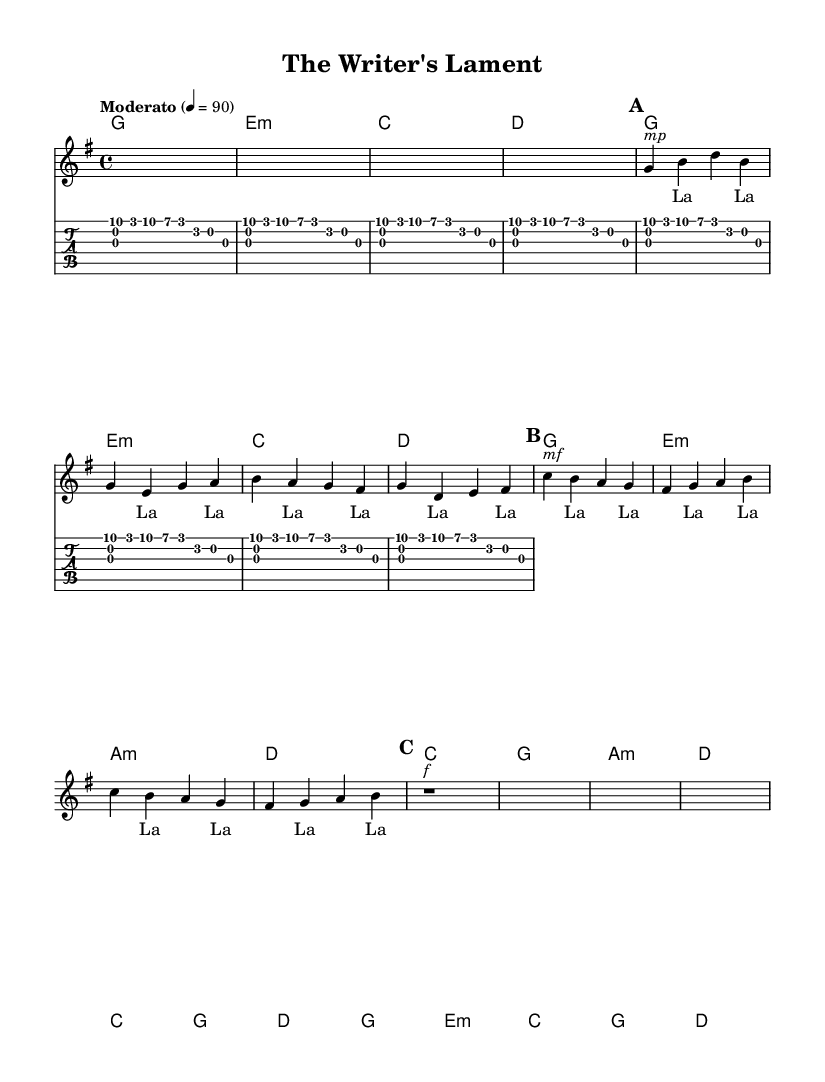What is the key signature of this music? The key signature is G major, which has one sharp (F#). This can be determined by looking at the key signature at the beginning of the staff, which indicates G major.
Answer: G major What is the time signature of this music? The time signature is 4/4, which is indicated at the beginning of the score. This means there are four beats in each measure and the quarter note gets one beat.
Answer: 4/4 What is the tempo marking of the piece? The tempo marking is "Moderato" at a speed of 90 beats per minute, specified at the beginning of the score. This indicates a moderate pace for the performance.
Answer: Moderato, 90 How many sections are there in the music? The music consists of three main sections: Verse, Chorus, and Bridge. This is indicated by the different subsections labeled within the score for better structure.
Answer: 3 Which chord is played in the first measure? The first measure contains the G major chord, which is represented by the notes played as fingerpicking patterns in the guitar part and also denoted in the chord names section.
Answer: G What is the dynamic marking at the beginning of the Verse? The dynamic marking at the beginning of the Verse is "mp" which stands for mezzo-piano, indicating a moderately soft volume for that section. This can be seen directly under the first note of the verse in the voice section.
Answer: mp How many measures are in the Chorus? There are four measures in the Chorus section. By counting the measures indicated between the start and end of the Chorus, we can determine that it consists of four complete measures.
Answer: 4 